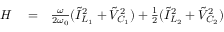<formula> <loc_0><loc_0><loc_500><loc_500>\begin{array} { r l r } { H } & = } & { \frac { \omega } { 2 \omega _ { 0 } } ( \tilde { I } _ { L _ { 1 } } ^ { 2 } + \tilde { V } _ { C _ { 1 } } ^ { 2 } ) + \frac { 1 } { 2 } ( \tilde { I } _ { L _ { 2 } } ^ { 2 } + \tilde { V } _ { C _ { 2 } } ^ { 2 } ) } \end{array}</formula> 